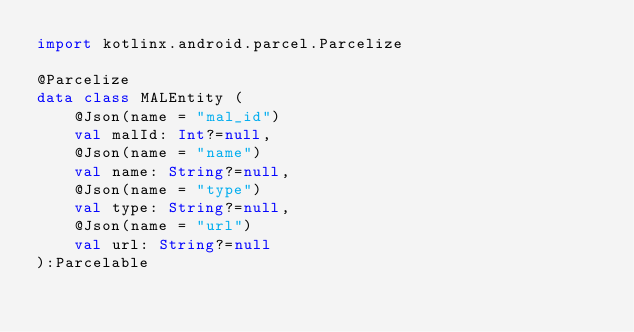<code> <loc_0><loc_0><loc_500><loc_500><_Kotlin_>import kotlinx.android.parcel.Parcelize

@Parcelize
data class MALEntity (
    @Json(name = "mal_id")
    val malId: Int?=null,
    @Json(name = "name")
    val name: String?=null,
    @Json(name = "type")
    val type: String?=null,
    @Json(name = "url")
    val url: String?=null
):Parcelable</code> 